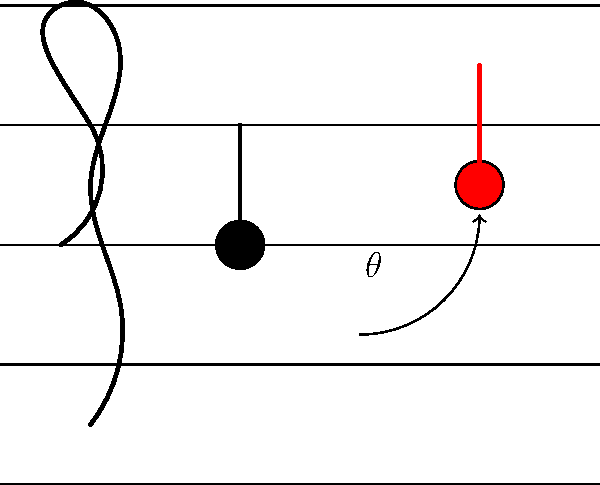As a pianist familiar with musical notation, consider the rotation of a quarter note on a staff. If the original note is on the third line from the bottom (B in treble clef) and is rotated counterclockwise to the space above (C), what is the angle of rotation $\theta$ in degrees? To solve this problem, let's follow these steps:

1) In standard musical notation, the staff consists of 5 lines and 4 spaces.

2) The distance between each line or space represents a pitch difference of one semitone.

3) The original note is on the 3rd line (B), and the rotated note is in the space above (C).

4) This represents a movement of 1 space, or 1 semitone.

5) In a complete rotation (360°), there are 12 semitones (one octave).

6) We can set up the proportion:
   $$\frac{\text{semitones moved}}{\text{total semitones}} = \frac{\text{angle rotated}}{360°}$$

7) Substituting our values:
   $$\frac{1}{12} = \frac{\theta}{360°}$$

8) Cross multiply:
   $$1 \cdot 360° = 12\theta$$

9) Solve for $\theta$:
   $$\theta = \frac{360°}{12} = 30°$$

Therefore, the angle of rotation is 30°.
Answer: $30°$ 